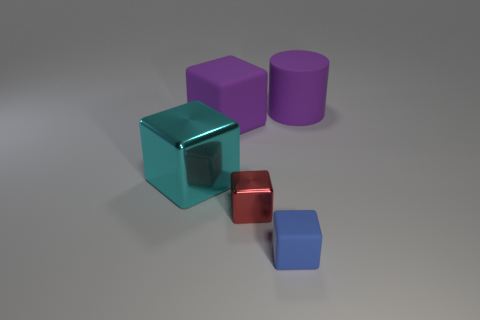Add 3 big purple matte cubes. How many objects exist? 8 Subtract all cylinders. How many objects are left? 4 Subtract all blue things. Subtract all tiny rubber blocks. How many objects are left? 3 Add 4 blue cubes. How many blue cubes are left? 5 Add 2 purple matte things. How many purple matte things exist? 4 Subtract 1 purple cylinders. How many objects are left? 4 